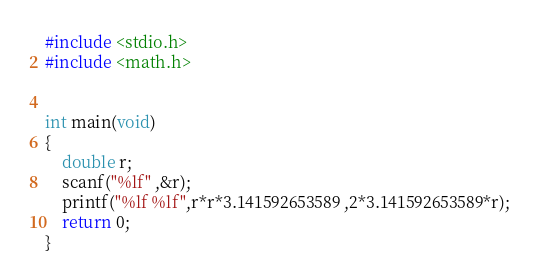<code> <loc_0><loc_0><loc_500><loc_500><_C_>#include <stdio.h>
#include <math.h>


int main(void)
{
	double r;
	scanf("%lf" ,&r);
	printf("%lf %lf",r*r*3.141592653589 ,2*3.141592653589*r);
	return 0;
}
</code> 